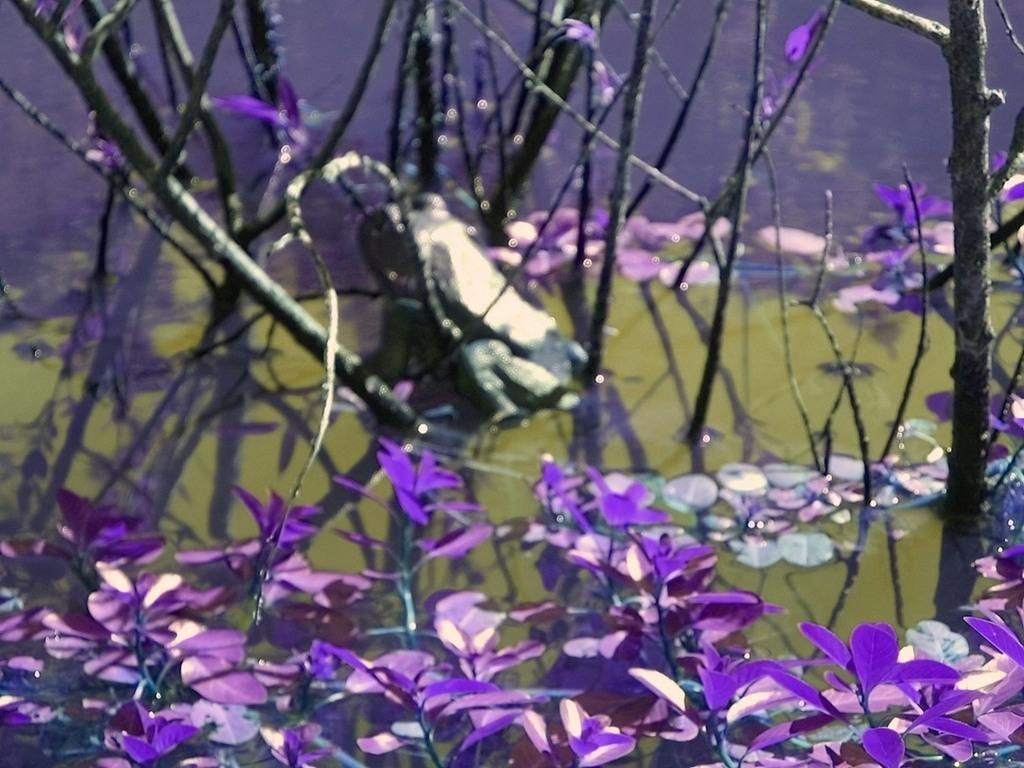How would you summarize this image in a sentence or two? In this image I can see there are leaves in purple color. In the middle it looks like an object, at the back side there is water. 